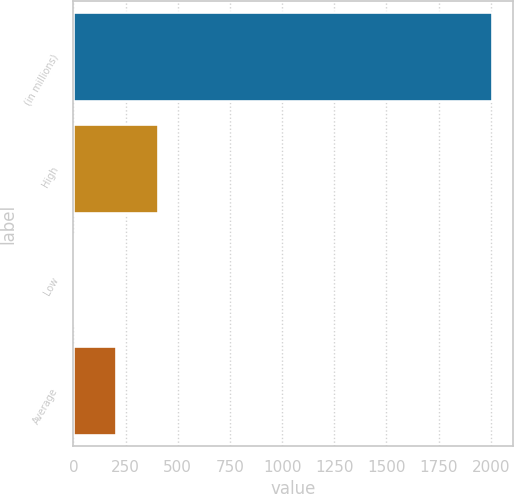<chart> <loc_0><loc_0><loc_500><loc_500><bar_chart><fcel>(in millions)<fcel>High<fcel>Low<fcel>Average<nl><fcel>2007<fcel>402.84<fcel>1.8<fcel>202.32<nl></chart> 